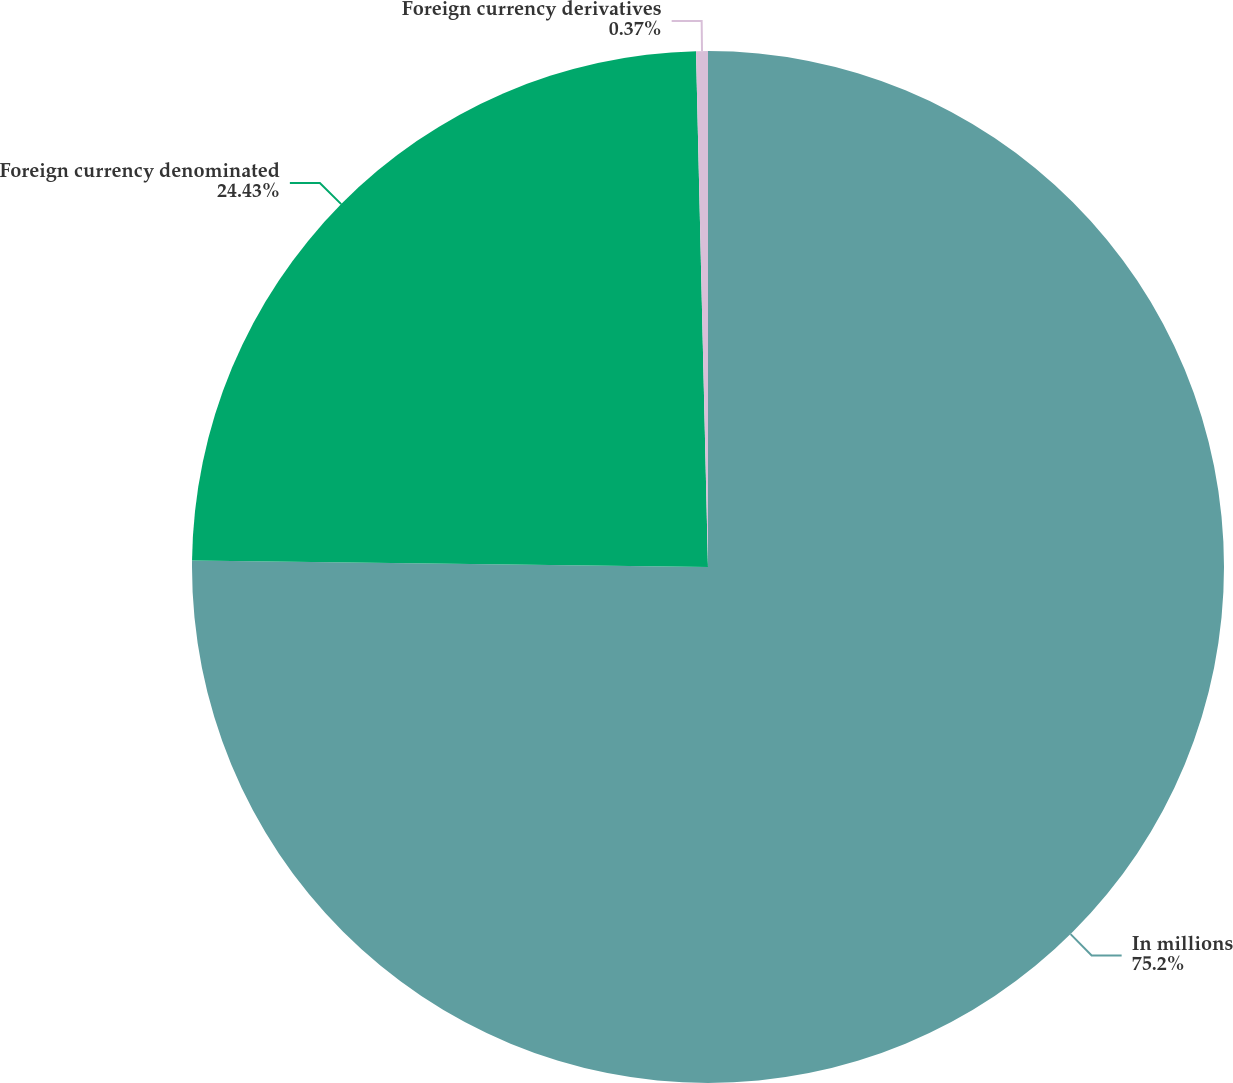<chart> <loc_0><loc_0><loc_500><loc_500><pie_chart><fcel>In millions<fcel>Foreign currency denominated<fcel>Foreign currency derivatives<nl><fcel>75.2%<fcel>24.43%<fcel>0.37%<nl></chart> 